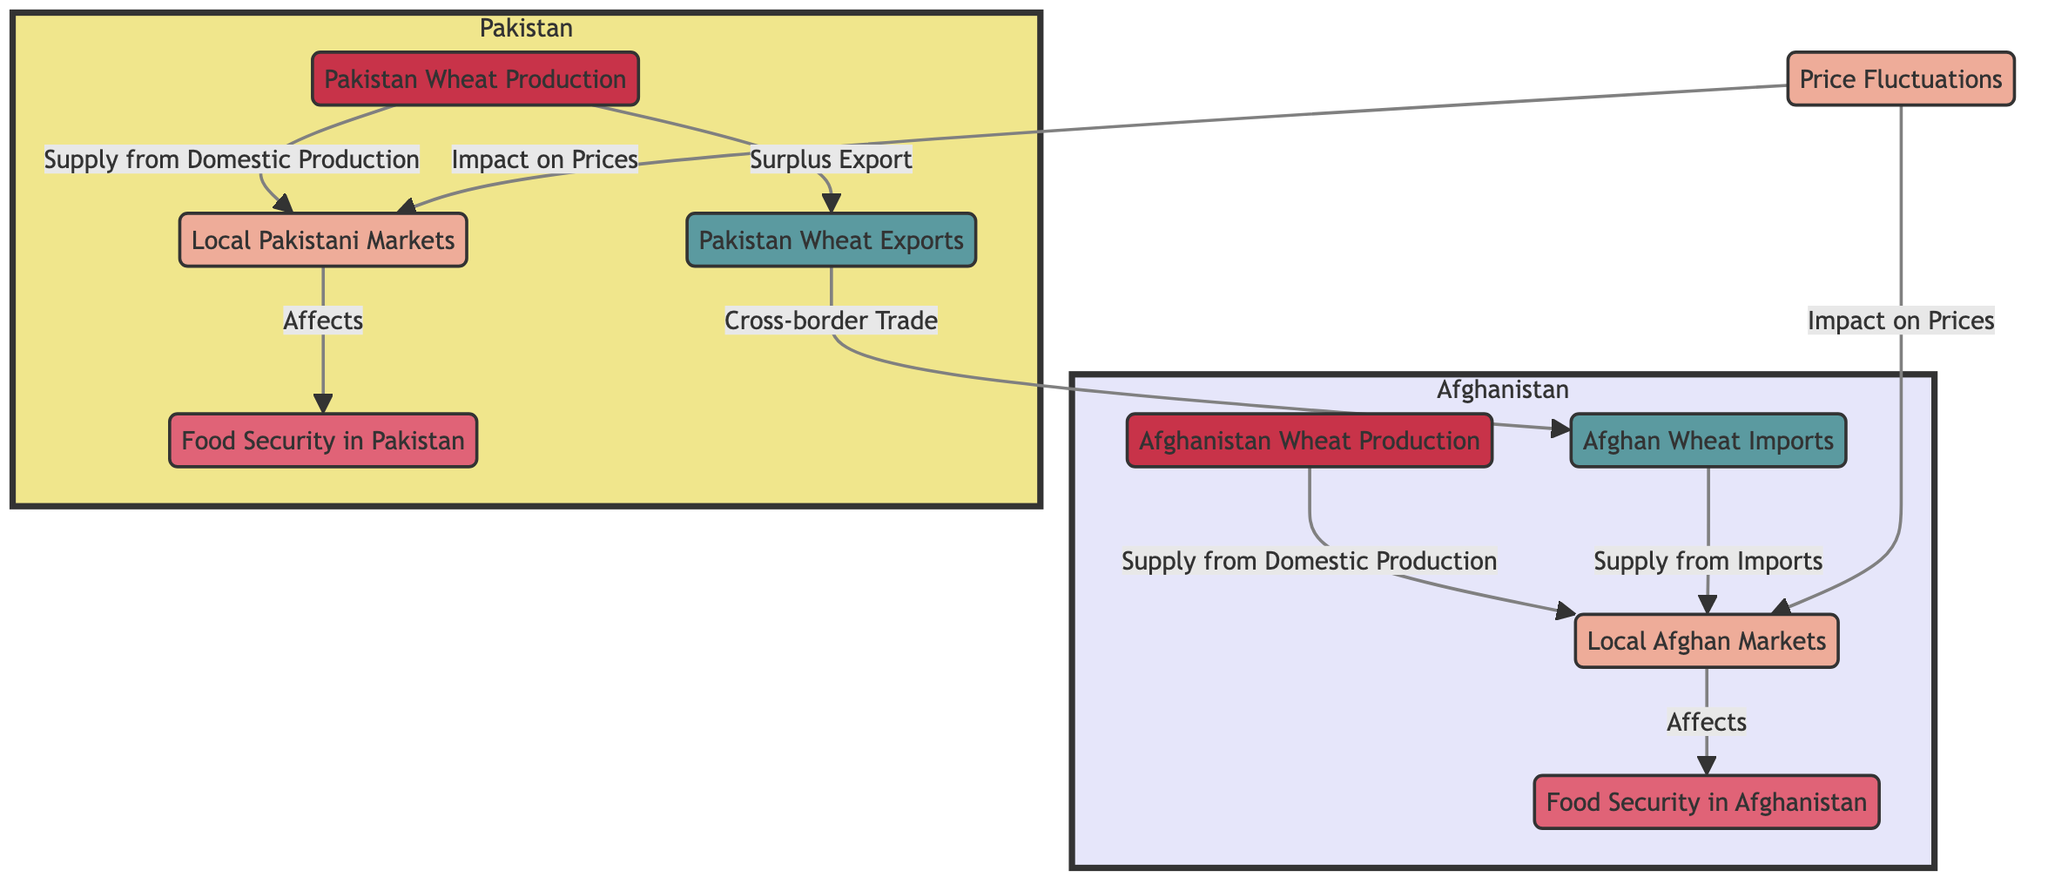What's the role of Afghanistan wheat production? Afghanistan wheat production supplies local Afghan markets, contributing to food security in Afghanistan.
Answer: Supply to local Afghan markets How many nodes are in the Afghanistan subgraph? The Afghanistan subgraph contains four nodes: Afghanistan wheat production, Afghan imports, local Afghan markets, and food security in Afghanistan.
Answer: Four What affects food security in Pakistan? Food security in Pakistan is affected by local Pakistani markets, which are supplied by domestic production and export of wheat from Pakistan.
Answer: Local Pakistani markets What connection exists between Pakistani exports and Afghan imports? Pakistani exports connect to Afghan imports through cross-border trade, allowing wheat from Pakistan to be supplied to Afghanistan.
Answer: Cross-border trade What impact do price fluctuations have? Price fluctuations impact prices in both local Afghan markets and local Pakistani markets, influencing food security in both countries.
Answer: Impact on prices Which node directly influences food security in Afghanistan? The local Afghan markets node directly influences food security in Afghanistan, as it supplies food to the population.
Answer: Local Afghan markets How do Afghan imports influence local markets in Afghanistan? Afghan imports supply local Afghan markets, augmenting the available wheat supply and thereby contributing to food security.
Answer: Supply from imports Which domestic production feeds into local Afghan markets? Afghanistan wheat production feeds into local Afghan markets, providing a source of wheat for the local population.
Answer: Afghanistan wheat production How do local markets in both countries relate to food security? Local markets in both Afghanistan and Pakistan are crucial as they directly affect their respective food security situations through the provision of wheat.
Answer: Local markets affect food security 